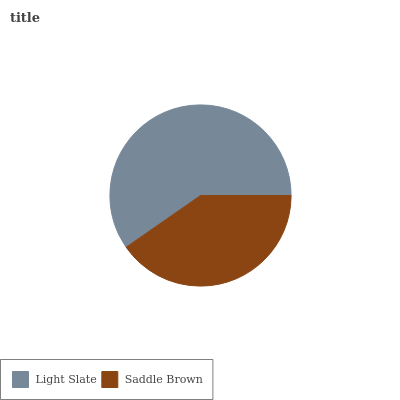Is Saddle Brown the minimum?
Answer yes or no. Yes. Is Light Slate the maximum?
Answer yes or no. Yes. Is Saddle Brown the maximum?
Answer yes or no. No. Is Light Slate greater than Saddle Brown?
Answer yes or no. Yes. Is Saddle Brown less than Light Slate?
Answer yes or no. Yes. Is Saddle Brown greater than Light Slate?
Answer yes or no. No. Is Light Slate less than Saddle Brown?
Answer yes or no. No. Is Light Slate the high median?
Answer yes or no. Yes. Is Saddle Brown the low median?
Answer yes or no. Yes. Is Saddle Brown the high median?
Answer yes or no. No. Is Light Slate the low median?
Answer yes or no. No. 